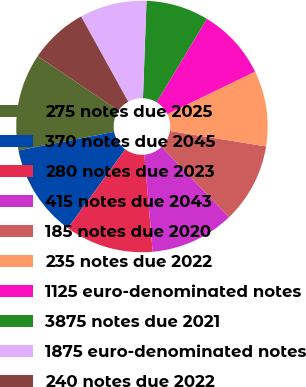Convert chart. <chart><loc_0><loc_0><loc_500><loc_500><pie_chart><fcel>275 notes due 2025<fcel>370 notes due 2045<fcel>280 notes due 2023<fcel>415 notes due 2043<fcel>185 notes due 2020<fcel>235 notes due 2022<fcel>1125 euro-denominated notes<fcel>3875 notes due 2021<fcel>1875 euro-denominated notes<fcel>240 notes due 2022<nl><fcel>12.49%<fcel>11.94%<fcel>11.38%<fcel>10.83%<fcel>10.28%<fcel>9.72%<fcel>9.17%<fcel>8.06%<fcel>8.62%<fcel>7.51%<nl></chart> 